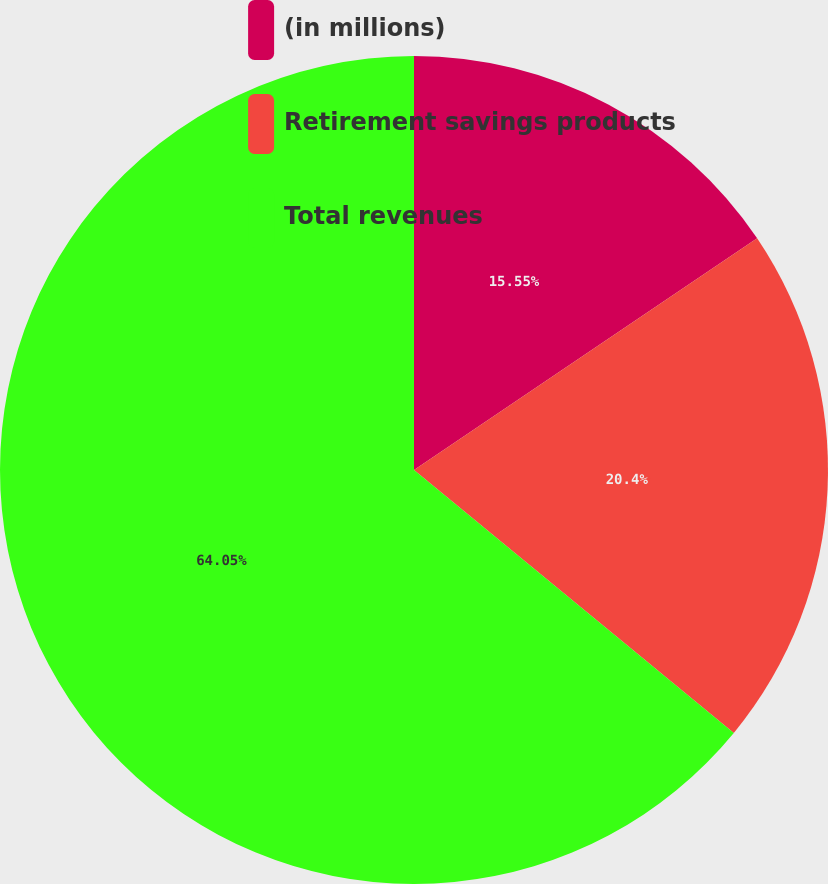Convert chart to OTSL. <chart><loc_0><loc_0><loc_500><loc_500><pie_chart><fcel>(in millions)<fcel>Retirement savings products<fcel>Total revenues<nl><fcel>15.55%<fcel>20.4%<fcel>64.05%<nl></chart> 